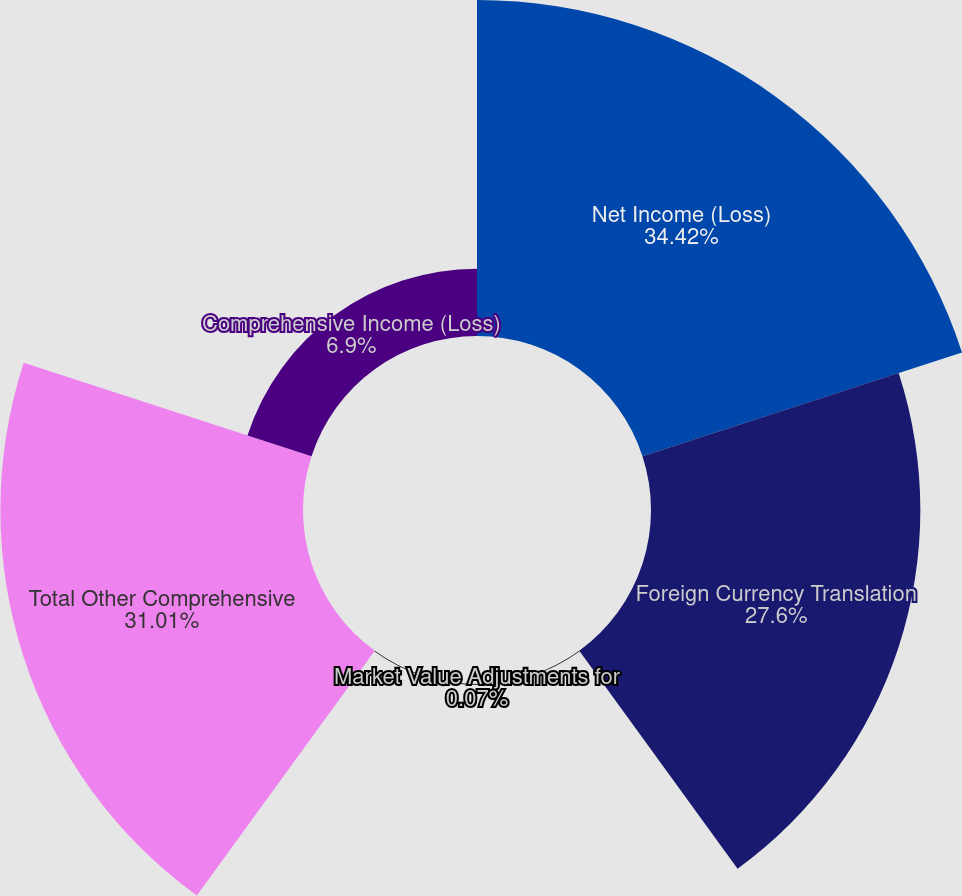<chart> <loc_0><loc_0><loc_500><loc_500><pie_chart><fcel>Net Income (Loss)<fcel>Foreign Currency Translation<fcel>Market Value Adjustments for<fcel>Total Other Comprehensive<fcel>Comprehensive Income (Loss)<nl><fcel>34.43%<fcel>27.6%<fcel>0.07%<fcel>31.01%<fcel>6.9%<nl></chart> 